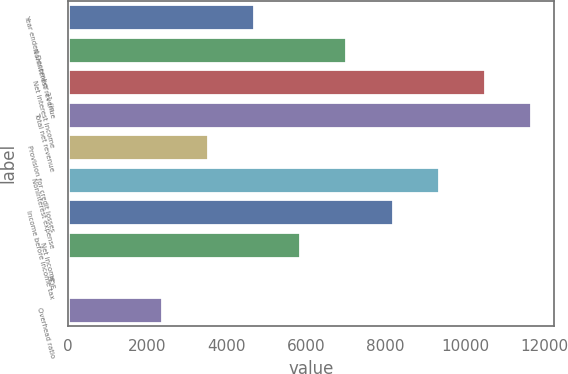<chart> <loc_0><loc_0><loc_500><loc_500><bar_chart><fcel>Year ended December 31 (in<fcel>Noninterest revenue<fcel>Net interest income<fcel>Total net revenue<fcel>Provision for credit losses<fcel>Noninterest expense<fcel>Income before income tax<fcel>Net income<fcel>ROE<fcel>Overhead ratio<nl><fcel>4686.2<fcel>7013.8<fcel>10505.2<fcel>11669<fcel>3522.4<fcel>9341.4<fcel>8177.6<fcel>5850<fcel>31<fcel>2358.6<nl></chart> 